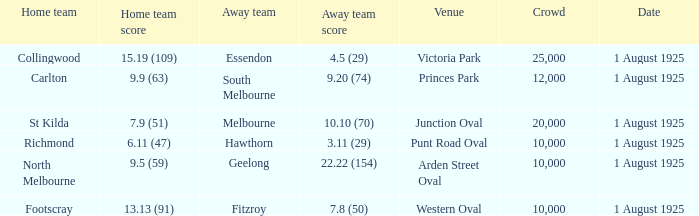5 (29), what was the audience size? 1.0. 